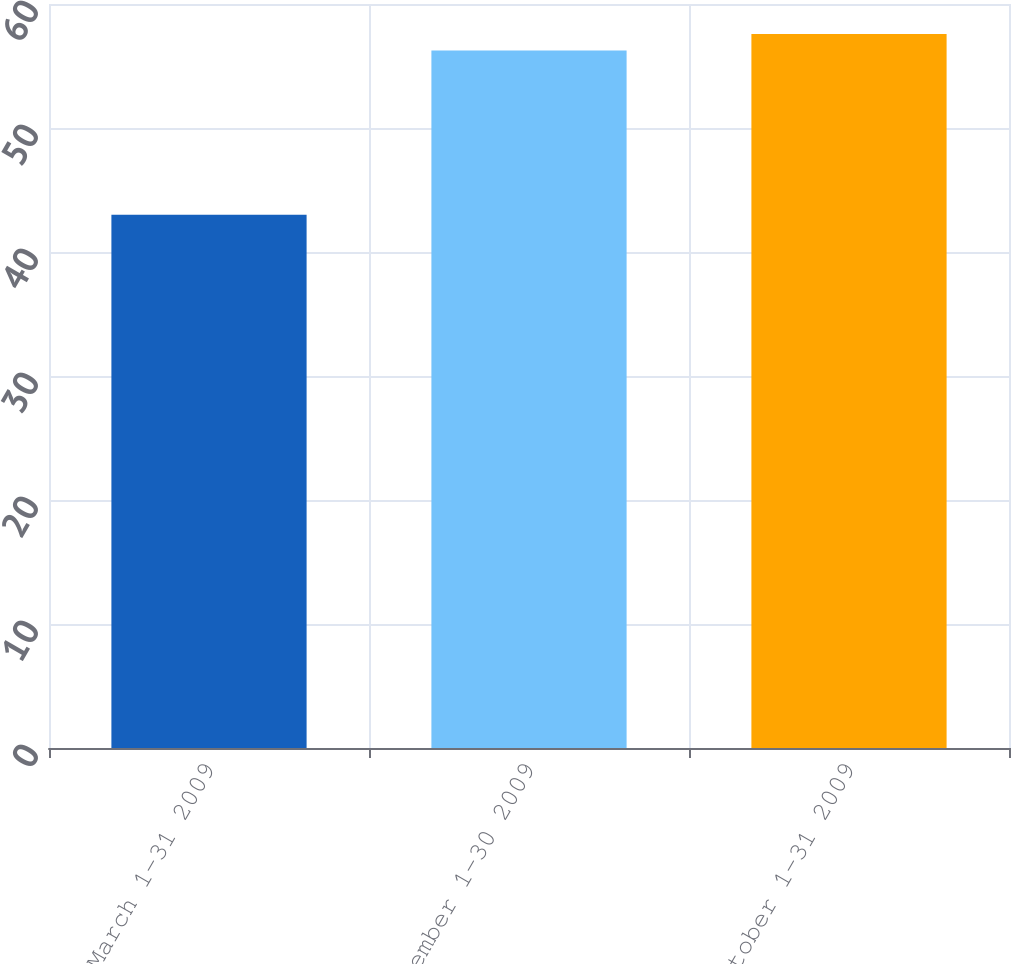Convert chart to OTSL. <chart><loc_0><loc_0><loc_500><loc_500><bar_chart><fcel>March 1-31 2009<fcel>September 1-30 2009<fcel>October 1-31 2009<nl><fcel>43.01<fcel>56.25<fcel>57.58<nl></chart> 